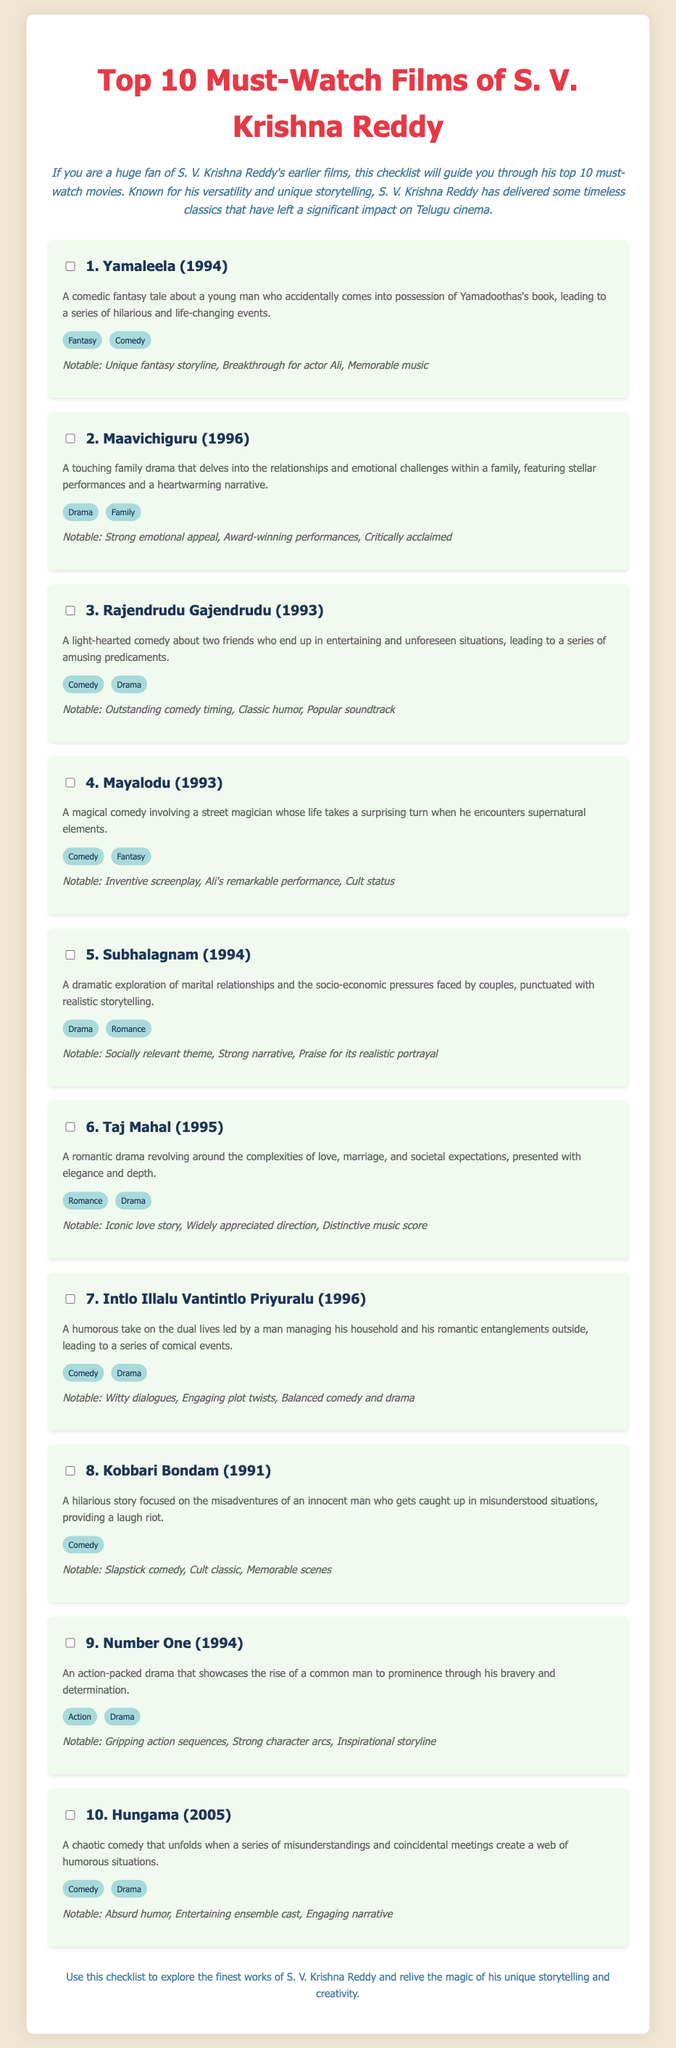What is the title of the first film on the list? The first film listed is "Yamaleela (1994)."
Answer: Yamaleela (1994) Which film is described as a romantic drama? The film "Taj Mahal" is identified as a romantic drama in the document.
Answer: Taj Mahal How many films make up the list of must-watch films? The document outlines a total of 10 must-watch films by S. V. Krishna Reddy.
Answer: 10 What genre does the film "Mayalodu" belong to? "Mayalodu" is categorized under the genres of Comedy and Fantasy.
Answer: Comedy, Fantasy Which film has the notable feature of a breakthrough for actor Ali? "Yamaleela" is noted for being a breakthrough for actor Ali.
Answer: Yamaleela What year was "Hungama" released? "Hungama" was released in the year 2005.
Answer: 2005 Which film features a narrative about managing dual lives? "Intlo Illalu Vantintlo Priyuralu" deals with managing dual lives as mentioned in the document.
Answer: Intlo Illalu Vantintlo Priyuralu What is the notable theme of "Subhalagnam"? "Subhalagnam" explores the theme of marital relationships and socio-economic pressures.
Answer: Marital relationships and socio-economic pressures What type of humor is prevalent in "Kobbari Bondam"? "Kobbari Bondam" is characterized by slapstick comedy.
Answer: Slapstick comedy 